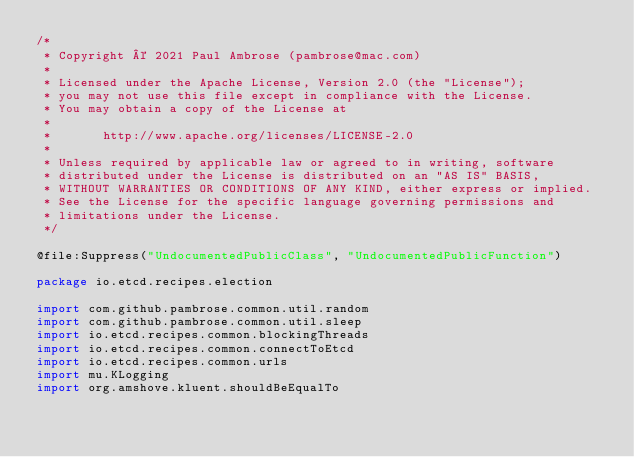Convert code to text. <code><loc_0><loc_0><loc_500><loc_500><_Kotlin_>/*
 * Copyright © 2021 Paul Ambrose (pambrose@mac.com)
 *
 * Licensed under the Apache License, Version 2.0 (the "License");
 * you may not use this file except in compliance with the License.
 * You may obtain a copy of the License at
 *
 *       http://www.apache.org/licenses/LICENSE-2.0
 *
 * Unless required by applicable law or agreed to in writing, software
 * distributed under the License is distributed on an "AS IS" BASIS,
 * WITHOUT WARRANTIES OR CONDITIONS OF ANY KIND, either express or implied.
 * See the License for the specific language governing permissions and
 * limitations under the License.
 */

@file:Suppress("UndocumentedPublicClass", "UndocumentedPublicFunction")

package io.etcd.recipes.election

import com.github.pambrose.common.util.random
import com.github.pambrose.common.util.sleep
import io.etcd.recipes.common.blockingThreads
import io.etcd.recipes.common.connectToEtcd
import io.etcd.recipes.common.urls
import mu.KLogging
import org.amshove.kluent.shouldBeEqualTo</code> 